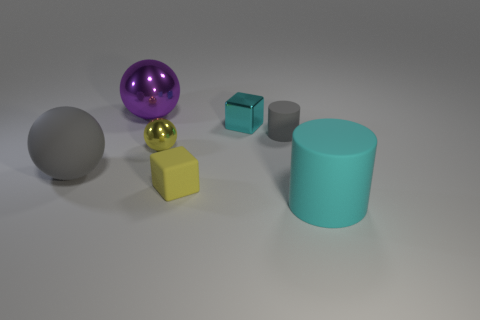What color is the sphere right of the sphere behind the yellow thing behind the tiny yellow rubber thing?
Provide a succinct answer. Yellow. What color is the other tiny rubber object that is the same shape as the tiny cyan object?
Offer a very short reply. Yellow. Are there the same number of rubber cubes behind the shiny cube and tiny gray metallic balls?
Your answer should be very brief. Yes. What number of spheres are either cyan objects or big purple things?
Ensure brevity in your answer.  1. There is a small cylinder that is made of the same material as the large cylinder; what is its color?
Ensure brevity in your answer.  Gray. Do the purple sphere and the block left of the tiny cyan cube have the same material?
Provide a short and direct response. No. What number of objects are purple balls or small red matte cylinders?
Give a very brief answer. 1. What material is the object that is the same color as the metallic block?
Give a very brief answer. Rubber. Is there a tiny cyan metallic object of the same shape as the big purple shiny thing?
Your response must be concise. No. How many rubber things are in front of the gray ball?
Offer a very short reply. 2. 